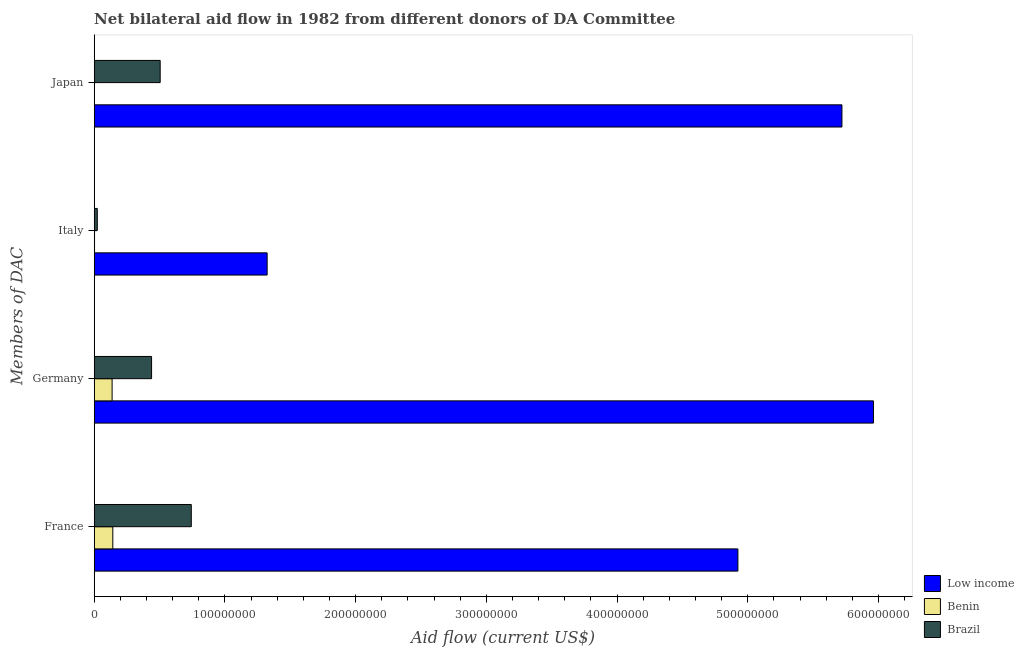How many different coloured bars are there?
Keep it short and to the point. 3. How many groups of bars are there?
Provide a short and direct response. 4. What is the amount of aid given by germany in Brazil?
Give a very brief answer. 4.39e+07. Across all countries, what is the maximum amount of aid given by germany?
Offer a very short reply. 5.96e+08. Across all countries, what is the minimum amount of aid given by italy?
Provide a short and direct response. 2.50e+05. In which country was the amount of aid given by italy minimum?
Your answer should be compact. Benin. What is the total amount of aid given by germany in the graph?
Make the answer very short. 6.54e+08. What is the difference between the amount of aid given by germany in Benin and that in Low income?
Your answer should be compact. -5.82e+08. What is the difference between the amount of aid given by germany in Low income and the amount of aid given by italy in Brazil?
Keep it short and to the point. 5.94e+08. What is the average amount of aid given by germany per country?
Keep it short and to the point. 2.18e+08. What is the difference between the amount of aid given by italy and amount of aid given by germany in Low income?
Your response must be concise. -4.64e+08. What is the ratio of the amount of aid given by italy in Brazil to that in Low income?
Your answer should be very brief. 0.02. Is the amount of aid given by italy in Benin less than that in Brazil?
Keep it short and to the point. Yes. Is the difference between the amount of aid given by italy in Low income and Brazil greater than the difference between the amount of aid given by japan in Low income and Brazil?
Offer a terse response. No. What is the difference between the highest and the second highest amount of aid given by japan?
Provide a short and direct response. 5.22e+08. What is the difference between the highest and the lowest amount of aid given by italy?
Provide a short and direct response. 1.32e+08. Is it the case that in every country, the sum of the amount of aid given by japan and amount of aid given by germany is greater than the sum of amount of aid given by italy and amount of aid given by france?
Ensure brevity in your answer.  No. What does the 3rd bar from the top in Japan represents?
Your answer should be compact. Low income. Is it the case that in every country, the sum of the amount of aid given by france and amount of aid given by germany is greater than the amount of aid given by italy?
Give a very brief answer. Yes. How many bars are there?
Keep it short and to the point. 12. How many countries are there in the graph?
Give a very brief answer. 3. Does the graph contain grids?
Your response must be concise. No. How many legend labels are there?
Offer a terse response. 3. What is the title of the graph?
Provide a short and direct response. Net bilateral aid flow in 1982 from different donors of DA Committee. What is the label or title of the Y-axis?
Ensure brevity in your answer.  Members of DAC. What is the Aid flow (current US$) of Low income in France?
Your response must be concise. 4.92e+08. What is the Aid flow (current US$) in Benin in France?
Your answer should be very brief. 1.42e+07. What is the Aid flow (current US$) in Brazil in France?
Ensure brevity in your answer.  7.43e+07. What is the Aid flow (current US$) of Low income in Germany?
Provide a succinct answer. 5.96e+08. What is the Aid flow (current US$) of Benin in Germany?
Ensure brevity in your answer.  1.37e+07. What is the Aid flow (current US$) in Brazil in Germany?
Your response must be concise. 4.39e+07. What is the Aid flow (current US$) of Low income in Italy?
Offer a terse response. 1.32e+08. What is the Aid flow (current US$) of Brazil in Italy?
Offer a very short reply. 2.37e+06. What is the Aid flow (current US$) in Low income in Japan?
Offer a terse response. 5.72e+08. What is the Aid flow (current US$) of Benin in Japan?
Ensure brevity in your answer.  1.90e+05. What is the Aid flow (current US$) of Brazil in Japan?
Your answer should be very brief. 5.05e+07. Across all Members of DAC, what is the maximum Aid flow (current US$) of Low income?
Provide a short and direct response. 5.96e+08. Across all Members of DAC, what is the maximum Aid flow (current US$) in Benin?
Offer a very short reply. 1.42e+07. Across all Members of DAC, what is the maximum Aid flow (current US$) in Brazil?
Provide a short and direct response. 7.43e+07. Across all Members of DAC, what is the minimum Aid flow (current US$) of Low income?
Make the answer very short. 1.32e+08. Across all Members of DAC, what is the minimum Aid flow (current US$) in Benin?
Provide a succinct answer. 1.90e+05. Across all Members of DAC, what is the minimum Aid flow (current US$) in Brazil?
Your response must be concise. 2.37e+06. What is the total Aid flow (current US$) in Low income in the graph?
Offer a very short reply. 1.79e+09. What is the total Aid flow (current US$) in Benin in the graph?
Provide a short and direct response. 2.84e+07. What is the total Aid flow (current US$) in Brazil in the graph?
Offer a terse response. 1.71e+08. What is the difference between the Aid flow (current US$) of Low income in France and that in Germany?
Provide a succinct answer. -1.04e+08. What is the difference between the Aid flow (current US$) in Benin in France and that in Germany?
Your answer should be compact. 5.40e+05. What is the difference between the Aid flow (current US$) in Brazil in France and that in Germany?
Ensure brevity in your answer.  3.04e+07. What is the difference between the Aid flow (current US$) of Low income in France and that in Italy?
Keep it short and to the point. 3.60e+08. What is the difference between the Aid flow (current US$) of Benin in France and that in Italy?
Make the answer very short. 1.40e+07. What is the difference between the Aid flow (current US$) of Brazil in France and that in Italy?
Your response must be concise. 7.19e+07. What is the difference between the Aid flow (current US$) of Low income in France and that in Japan?
Your answer should be very brief. -7.96e+07. What is the difference between the Aid flow (current US$) in Benin in France and that in Japan?
Your response must be concise. 1.40e+07. What is the difference between the Aid flow (current US$) of Brazil in France and that in Japan?
Offer a terse response. 2.38e+07. What is the difference between the Aid flow (current US$) of Low income in Germany and that in Italy?
Offer a very short reply. 4.64e+08. What is the difference between the Aid flow (current US$) of Benin in Germany and that in Italy?
Your response must be concise. 1.34e+07. What is the difference between the Aid flow (current US$) of Brazil in Germany and that in Italy?
Make the answer very short. 4.15e+07. What is the difference between the Aid flow (current US$) in Low income in Germany and that in Japan?
Offer a terse response. 2.41e+07. What is the difference between the Aid flow (current US$) in Benin in Germany and that in Japan?
Offer a terse response. 1.35e+07. What is the difference between the Aid flow (current US$) of Brazil in Germany and that in Japan?
Your answer should be very brief. -6.58e+06. What is the difference between the Aid flow (current US$) in Low income in Italy and that in Japan?
Offer a terse response. -4.40e+08. What is the difference between the Aid flow (current US$) of Brazil in Italy and that in Japan?
Your answer should be very brief. -4.81e+07. What is the difference between the Aid flow (current US$) in Low income in France and the Aid flow (current US$) in Benin in Germany?
Your answer should be very brief. 4.79e+08. What is the difference between the Aid flow (current US$) of Low income in France and the Aid flow (current US$) of Brazil in Germany?
Ensure brevity in your answer.  4.49e+08. What is the difference between the Aid flow (current US$) in Benin in France and the Aid flow (current US$) in Brazil in Germany?
Your answer should be very brief. -2.96e+07. What is the difference between the Aid flow (current US$) of Low income in France and the Aid flow (current US$) of Benin in Italy?
Offer a terse response. 4.92e+08. What is the difference between the Aid flow (current US$) in Low income in France and the Aid flow (current US$) in Brazil in Italy?
Offer a terse response. 4.90e+08. What is the difference between the Aid flow (current US$) of Benin in France and the Aid flow (current US$) of Brazil in Italy?
Your answer should be very brief. 1.19e+07. What is the difference between the Aid flow (current US$) of Low income in France and the Aid flow (current US$) of Benin in Japan?
Your answer should be very brief. 4.92e+08. What is the difference between the Aid flow (current US$) in Low income in France and the Aid flow (current US$) in Brazil in Japan?
Your response must be concise. 4.42e+08. What is the difference between the Aid flow (current US$) in Benin in France and the Aid flow (current US$) in Brazil in Japan?
Keep it short and to the point. -3.62e+07. What is the difference between the Aid flow (current US$) in Low income in Germany and the Aid flow (current US$) in Benin in Italy?
Make the answer very short. 5.96e+08. What is the difference between the Aid flow (current US$) in Low income in Germany and the Aid flow (current US$) in Brazil in Italy?
Keep it short and to the point. 5.94e+08. What is the difference between the Aid flow (current US$) of Benin in Germany and the Aid flow (current US$) of Brazil in Italy?
Offer a very short reply. 1.13e+07. What is the difference between the Aid flow (current US$) in Low income in Germany and the Aid flow (current US$) in Benin in Japan?
Offer a terse response. 5.96e+08. What is the difference between the Aid flow (current US$) in Low income in Germany and the Aid flow (current US$) in Brazil in Japan?
Offer a terse response. 5.46e+08. What is the difference between the Aid flow (current US$) in Benin in Germany and the Aid flow (current US$) in Brazil in Japan?
Your answer should be very brief. -3.68e+07. What is the difference between the Aid flow (current US$) of Low income in Italy and the Aid flow (current US$) of Benin in Japan?
Keep it short and to the point. 1.32e+08. What is the difference between the Aid flow (current US$) in Low income in Italy and the Aid flow (current US$) in Brazil in Japan?
Your response must be concise. 8.18e+07. What is the difference between the Aid flow (current US$) of Benin in Italy and the Aid flow (current US$) of Brazil in Japan?
Offer a very short reply. -5.02e+07. What is the average Aid flow (current US$) in Low income per Members of DAC?
Keep it short and to the point. 4.48e+08. What is the average Aid flow (current US$) in Benin per Members of DAC?
Offer a very short reply. 7.10e+06. What is the average Aid flow (current US$) of Brazil per Members of DAC?
Give a very brief answer. 4.28e+07. What is the difference between the Aid flow (current US$) of Low income and Aid flow (current US$) of Benin in France?
Make the answer very short. 4.78e+08. What is the difference between the Aid flow (current US$) in Low income and Aid flow (current US$) in Brazil in France?
Keep it short and to the point. 4.18e+08. What is the difference between the Aid flow (current US$) of Benin and Aid flow (current US$) of Brazil in France?
Your answer should be compact. -6.00e+07. What is the difference between the Aid flow (current US$) in Low income and Aid flow (current US$) in Benin in Germany?
Offer a very short reply. 5.82e+08. What is the difference between the Aid flow (current US$) of Low income and Aid flow (current US$) of Brazil in Germany?
Keep it short and to the point. 5.52e+08. What is the difference between the Aid flow (current US$) in Benin and Aid flow (current US$) in Brazil in Germany?
Your answer should be very brief. -3.02e+07. What is the difference between the Aid flow (current US$) of Low income and Aid flow (current US$) of Benin in Italy?
Your response must be concise. 1.32e+08. What is the difference between the Aid flow (current US$) in Low income and Aid flow (current US$) in Brazil in Italy?
Make the answer very short. 1.30e+08. What is the difference between the Aid flow (current US$) of Benin and Aid flow (current US$) of Brazil in Italy?
Provide a short and direct response. -2.12e+06. What is the difference between the Aid flow (current US$) in Low income and Aid flow (current US$) in Benin in Japan?
Provide a short and direct response. 5.72e+08. What is the difference between the Aid flow (current US$) in Low income and Aid flow (current US$) in Brazil in Japan?
Offer a very short reply. 5.22e+08. What is the difference between the Aid flow (current US$) of Benin and Aid flow (current US$) of Brazil in Japan?
Offer a terse response. -5.03e+07. What is the ratio of the Aid flow (current US$) in Low income in France to that in Germany?
Give a very brief answer. 0.83. What is the ratio of the Aid flow (current US$) in Benin in France to that in Germany?
Your answer should be very brief. 1.04. What is the ratio of the Aid flow (current US$) of Brazil in France to that in Germany?
Your answer should be compact. 1.69. What is the ratio of the Aid flow (current US$) of Low income in France to that in Italy?
Provide a succinct answer. 3.72. What is the ratio of the Aid flow (current US$) of Benin in France to that in Italy?
Make the answer very short. 56.96. What is the ratio of the Aid flow (current US$) of Brazil in France to that in Italy?
Make the answer very short. 31.34. What is the ratio of the Aid flow (current US$) of Low income in France to that in Japan?
Give a very brief answer. 0.86. What is the ratio of the Aid flow (current US$) of Benin in France to that in Japan?
Your answer should be compact. 74.95. What is the ratio of the Aid flow (current US$) of Brazil in France to that in Japan?
Your answer should be very brief. 1.47. What is the ratio of the Aid flow (current US$) of Low income in Germany to that in Italy?
Keep it short and to the point. 4.51. What is the ratio of the Aid flow (current US$) in Benin in Germany to that in Italy?
Offer a terse response. 54.8. What is the ratio of the Aid flow (current US$) in Brazil in Germany to that in Italy?
Provide a short and direct response. 18.52. What is the ratio of the Aid flow (current US$) of Low income in Germany to that in Japan?
Your answer should be compact. 1.04. What is the ratio of the Aid flow (current US$) of Benin in Germany to that in Japan?
Offer a very short reply. 72.11. What is the ratio of the Aid flow (current US$) in Brazil in Germany to that in Japan?
Your response must be concise. 0.87. What is the ratio of the Aid flow (current US$) of Low income in Italy to that in Japan?
Provide a short and direct response. 0.23. What is the ratio of the Aid flow (current US$) in Benin in Italy to that in Japan?
Make the answer very short. 1.32. What is the ratio of the Aid flow (current US$) of Brazil in Italy to that in Japan?
Keep it short and to the point. 0.05. What is the difference between the highest and the second highest Aid flow (current US$) in Low income?
Your response must be concise. 2.41e+07. What is the difference between the highest and the second highest Aid flow (current US$) of Benin?
Offer a terse response. 5.40e+05. What is the difference between the highest and the second highest Aid flow (current US$) in Brazil?
Keep it short and to the point. 2.38e+07. What is the difference between the highest and the lowest Aid flow (current US$) of Low income?
Your answer should be very brief. 4.64e+08. What is the difference between the highest and the lowest Aid flow (current US$) in Benin?
Provide a short and direct response. 1.40e+07. What is the difference between the highest and the lowest Aid flow (current US$) of Brazil?
Offer a terse response. 7.19e+07. 